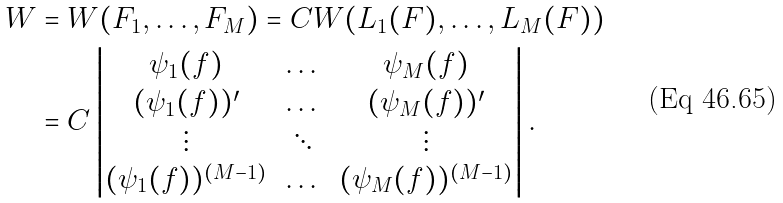<formula> <loc_0><loc_0><loc_500><loc_500>W & = W ( F _ { 1 } , \dots , F _ { M } ) = C W ( L _ { 1 } ( F ) , \dots , L _ { M } ( F ) ) \\ & = C \begin{vmatrix} \psi _ { 1 } ( f ) & \dots & \psi _ { M } ( f ) \\ ( \psi _ { 1 } ( f ) ) ^ { \prime } & \dots & ( \psi _ { M } ( f ) ) ^ { \prime } \\ \vdots & \ddots & \vdots \\ ( \psi _ { 1 } ( f ) ) ^ { ( M - 1 ) } & \dots & ( \psi _ { M } ( f ) ) ^ { ( M - 1 ) } \end{vmatrix} .</formula> 